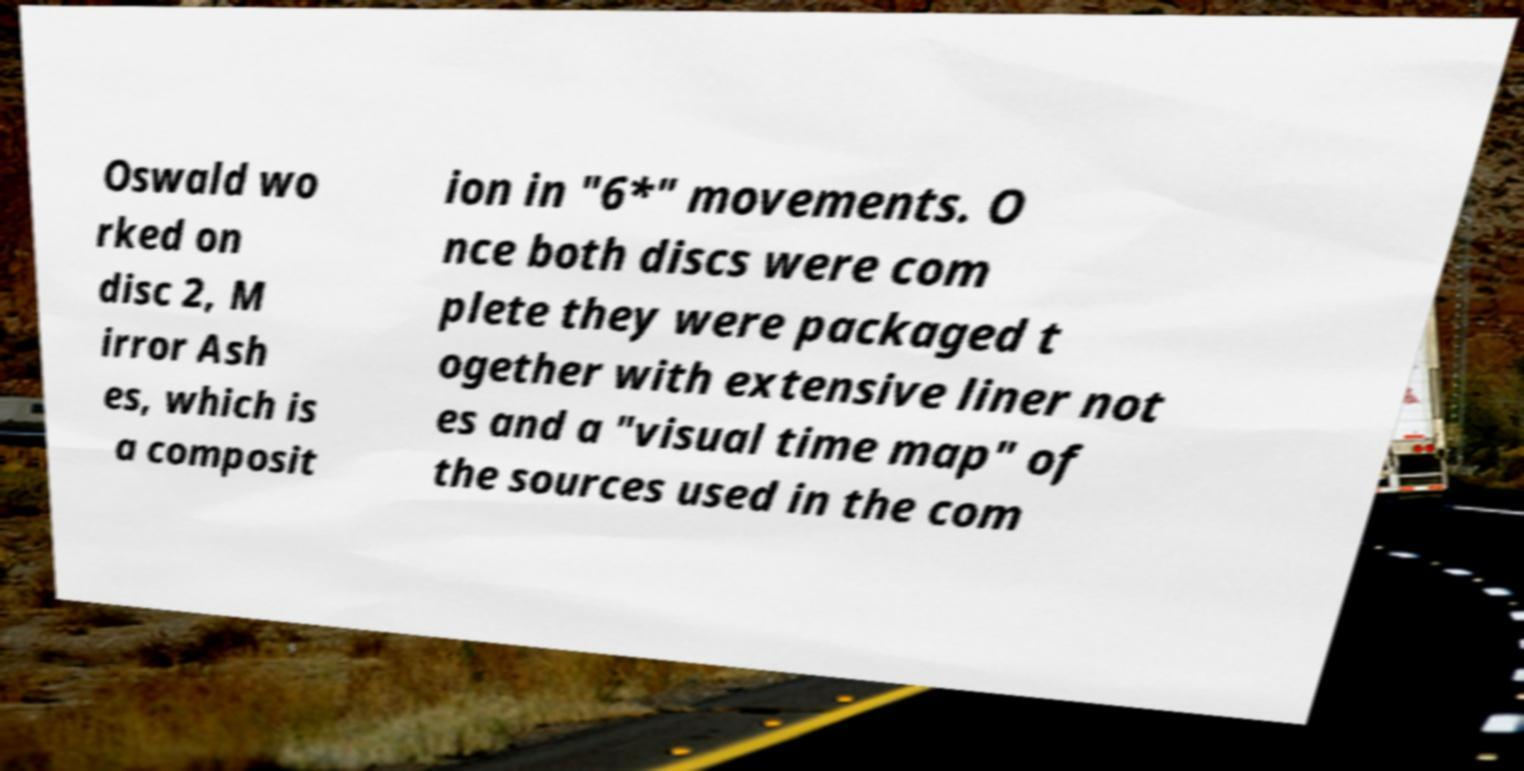Could you extract and type out the text from this image? Oswald wo rked on disc 2, M irror Ash es, which is a composit ion in "6*" movements. O nce both discs were com plete they were packaged t ogether with extensive liner not es and a "visual time map" of the sources used in the com 